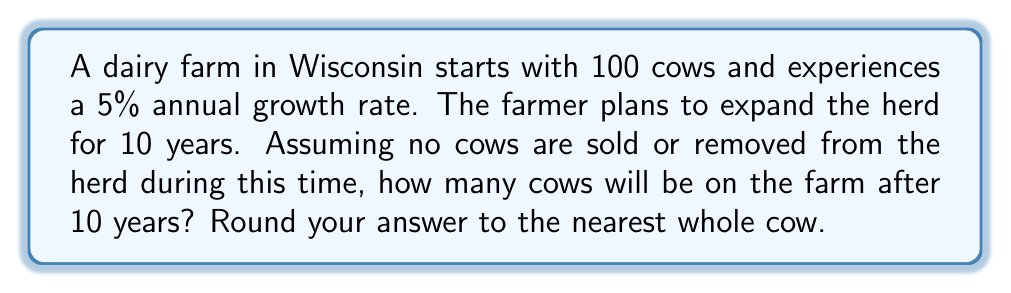Can you solve this math problem? To solve this problem, we'll use the exponential growth model:

$$P(t) = P_0 \cdot (1 + r)^t$$

Where:
$P(t)$ = Population at time $t$
$P_0$ = Initial population
$r$ = Growth rate (as a decimal)
$t$ = Time (in years)

Given:
$P_0 = 100$ cows
$r = 5\% = 0.05$
$t = 10$ years

Let's plug these values into the formula:

$$P(10) = 100 \cdot (1 + 0.05)^{10}$$

Now, let's calculate step-by-step:

1. $(1 + 0.05) = 1.05$
2. $(1.05)^{10} \approx 1.6288946$
3. $100 \cdot 1.6288946 \approx 162.88946$

Rounding to the nearest whole cow:

$162.88946 \approx 163$ cows
Answer: 163 cows 